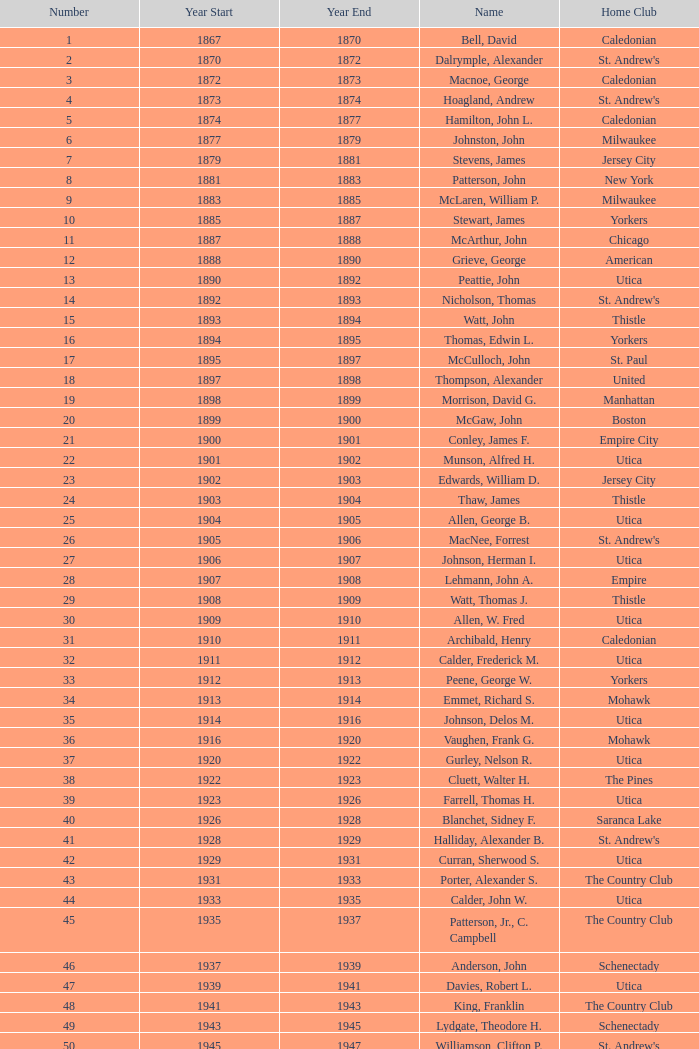Which Year Start has a Number of 28? 1907.0. 